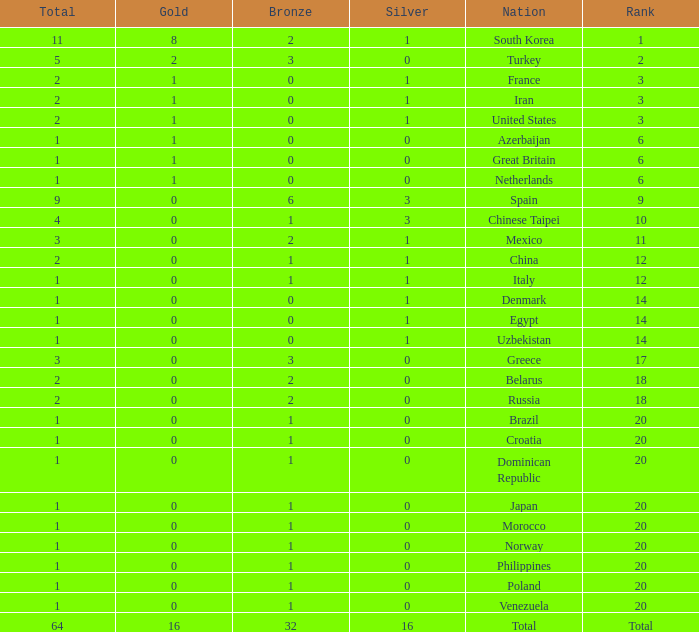What is the average number of bronze medals of the Philippines, which has more than 0 gold? None. 